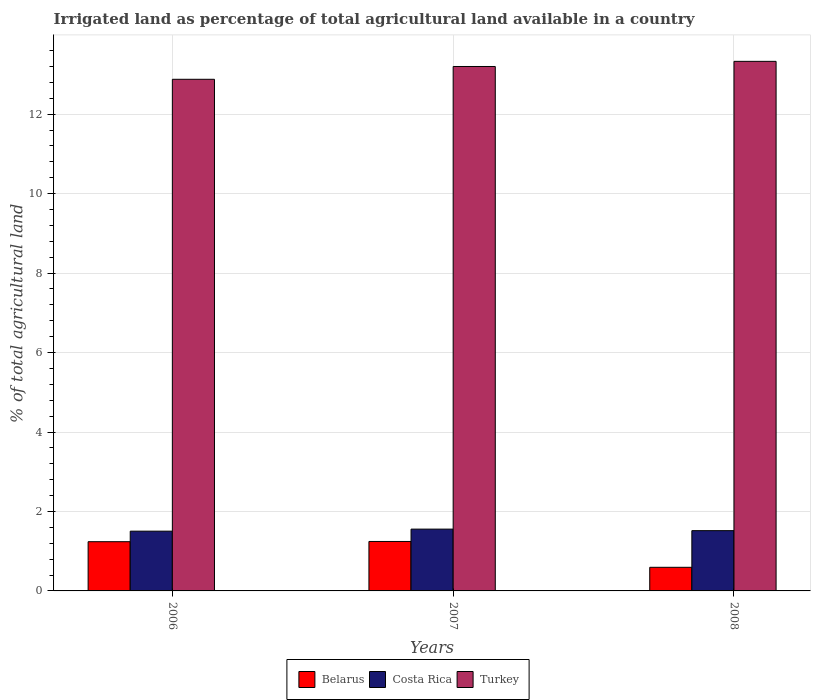How many bars are there on the 3rd tick from the left?
Offer a very short reply. 3. In how many cases, is the number of bars for a given year not equal to the number of legend labels?
Keep it short and to the point. 0. What is the percentage of irrigated land in Belarus in 2006?
Make the answer very short. 1.24. Across all years, what is the maximum percentage of irrigated land in Belarus?
Your response must be concise. 1.24. Across all years, what is the minimum percentage of irrigated land in Costa Rica?
Provide a short and direct response. 1.5. What is the total percentage of irrigated land in Costa Rica in the graph?
Provide a succinct answer. 4.58. What is the difference between the percentage of irrigated land in Belarus in 2006 and that in 2008?
Ensure brevity in your answer.  0.64. What is the difference between the percentage of irrigated land in Turkey in 2008 and the percentage of irrigated land in Belarus in 2006?
Keep it short and to the point. 12.09. What is the average percentage of irrigated land in Belarus per year?
Keep it short and to the point. 1.03. In the year 2008, what is the difference between the percentage of irrigated land in Costa Rica and percentage of irrigated land in Belarus?
Offer a very short reply. 0.92. What is the ratio of the percentage of irrigated land in Costa Rica in 2007 to that in 2008?
Give a very brief answer. 1.03. Is the percentage of irrigated land in Belarus in 2006 less than that in 2008?
Keep it short and to the point. No. Is the difference between the percentage of irrigated land in Costa Rica in 2007 and 2008 greater than the difference between the percentage of irrigated land in Belarus in 2007 and 2008?
Ensure brevity in your answer.  No. What is the difference between the highest and the second highest percentage of irrigated land in Turkey?
Ensure brevity in your answer.  0.13. What is the difference between the highest and the lowest percentage of irrigated land in Turkey?
Keep it short and to the point. 0.45. Is the sum of the percentage of irrigated land in Turkey in 2007 and 2008 greater than the maximum percentage of irrigated land in Costa Rica across all years?
Your answer should be compact. Yes. What does the 1st bar from the left in 2006 represents?
Offer a terse response. Belarus. Is it the case that in every year, the sum of the percentage of irrigated land in Turkey and percentage of irrigated land in Costa Rica is greater than the percentage of irrigated land in Belarus?
Provide a succinct answer. Yes. How many bars are there?
Your answer should be very brief. 9. What is the difference between two consecutive major ticks on the Y-axis?
Your answer should be compact. 2. What is the title of the graph?
Offer a very short reply. Irrigated land as percentage of total agricultural land available in a country. Does "Czech Republic" appear as one of the legend labels in the graph?
Give a very brief answer. No. What is the label or title of the Y-axis?
Provide a succinct answer. % of total agricultural land. What is the % of total agricultural land in Belarus in 2006?
Your answer should be compact. 1.24. What is the % of total agricultural land of Costa Rica in 2006?
Give a very brief answer. 1.5. What is the % of total agricultural land in Turkey in 2006?
Your response must be concise. 12.88. What is the % of total agricultural land of Belarus in 2007?
Offer a very short reply. 1.24. What is the % of total agricultural land of Costa Rica in 2007?
Ensure brevity in your answer.  1.56. What is the % of total agricultural land in Turkey in 2007?
Give a very brief answer. 13.2. What is the % of total agricultural land in Belarus in 2008?
Offer a terse response. 0.59. What is the % of total agricultural land in Costa Rica in 2008?
Keep it short and to the point. 1.52. What is the % of total agricultural land in Turkey in 2008?
Provide a succinct answer. 13.33. Across all years, what is the maximum % of total agricultural land in Belarus?
Provide a succinct answer. 1.24. Across all years, what is the maximum % of total agricultural land in Costa Rica?
Provide a short and direct response. 1.56. Across all years, what is the maximum % of total agricultural land of Turkey?
Your answer should be compact. 13.33. Across all years, what is the minimum % of total agricultural land in Belarus?
Your response must be concise. 0.59. Across all years, what is the minimum % of total agricultural land of Costa Rica?
Offer a very short reply. 1.5. Across all years, what is the minimum % of total agricultural land of Turkey?
Your response must be concise. 12.88. What is the total % of total agricultural land of Belarus in the graph?
Offer a very short reply. 3.08. What is the total % of total agricultural land of Costa Rica in the graph?
Your response must be concise. 4.58. What is the total % of total agricultural land of Turkey in the graph?
Offer a very short reply. 39.41. What is the difference between the % of total agricultural land in Belarus in 2006 and that in 2007?
Offer a very short reply. -0.01. What is the difference between the % of total agricultural land of Costa Rica in 2006 and that in 2007?
Keep it short and to the point. -0.05. What is the difference between the % of total agricultural land of Turkey in 2006 and that in 2007?
Make the answer very short. -0.32. What is the difference between the % of total agricultural land of Belarus in 2006 and that in 2008?
Offer a very short reply. 0.64. What is the difference between the % of total agricultural land in Costa Rica in 2006 and that in 2008?
Make the answer very short. -0.01. What is the difference between the % of total agricultural land in Turkey in 2006 and that in 2008?
Make the answer very short. -0.45. What is the difference between the % of total agricultural land in Belarus in 2007 and that in 2008?
Offer a very short reply. 0.65. What is the difference between the % of total agricultural land of Costa Rica in 2007 and that in 2008?
Make the answer very short. 0.04. What is the difference between the % of total agricultural land in Turkey in 2007 and that in 2008?
Make the answer very short. -0.13. What is the difference between the % of total agricultural land in Belarus in 2006 and the % of total agricultural land in Costa Rica in 2007?
Provide a short and direct response. -0.32. What is the difference between the % of total agricultural land of Belarus in 2006 and the % of total agricultural land of Turkey in 2007?
Provide a short and direct response. -11.96. What is the difference between the % of total agricultural land of Costa Rica in 2006 and the % of total agricultural land of Turkey in 2007?
Make the answer very short. -11.7. What is the difference between the % of total agricultural land of Belarus in 2006 and the % of total agricultural land of Costa Rica in 2008?
Your answer should be very brief. -0.28. What is the difference between the % of total agricultural land in Belarus in 2006 and the % of total agricultural land in Turkey in 2008?
Offer a terse response. -12.09. What is the difference between the % of total agricultural land of Costa Rica in 2006 and the % of total agricultural land of Turkey in 2008?
Keep it short and to the point. -11.83. What is the difference between the % of total agricultural land in Belarus in 2007 and the % of total agricultural land in Costa Rica in 2008?
Your response must be concise. -0.27. What is the difference between the % of total agricultural land in Belarus in 2007 and the % of total agricultural land in Turkey in 2008?
Offer a terse response. -12.09. What is the difference between the % of total agricultural land in Costa Rica in 2007 and the % of total agricultural land in Turkey in 2008?
Give a very brief answer. -11.77. What is the average % of total agricultural land in Belarus per year?
Provide a succinct answer. 1.03. What is the average % of total agricultural land of Costa Rica per year?
Ensure brevity in your answer.  1.53. What is the average % of total agricultural land in Turkey per year?
Ensure brevity in your answer.  13.14. In the year 2006, what is the difference between the % of total agricultural land in Belarus and % of total agricultural land in Costa Rica?
Your answer should be compact. -0.27. In the year 2006, what is the difference between the % of total agricultural land of Belarus and % of total agricultural land of Turkey?
Provide a succinct answer. -11.64. In the year 2006, what is the difference between the % of total agricultural land of Costa Rica and % of total agricultural land of Turkey?
Your answer should be very brief. -11.37. In the year 2007, what is the difference between the % of total agricultural land of Belarus and % of total agricultural land of Costa Rica?
Keep it short and to the point. -0.31. In the year 2007, what is the difference between the % of total agricultural land in Belarus and % of total agricultural land in Turkey?
Your answer should be very brief. -11.96. In the year 2007, what is the difference between the % of total agricultural land in Costa Rica and % of total agricultural land in Turkey?
Ensure brevity in your answer.  -11.65. In the year 2008, what is the difference between the % of total agricultural land in Belarus and % of total agricultural land in Costa Rica?
Make the answer very short. -0.92. In the year 2008, what is the difference between the % of total agricultural land of Belarus and % of total agricultural land of Turkey?
Give a very brief answer. -12.74. In the year 2008, what is the difference between the % of total agricultural land of Costa Rica and % of total agricultural land of Turkey?
Make the answer very short. -11.81. What is the ratio of the % of total agricultural land in Belarus in 2006 to that in 2007?
Offer a terse response. 1. What is the ratio of the % of total agricultural land in Costa Rica in 2006 to that in 2007?
Give a very brief answer. 0.97. What is the ratio of the % of total agricultural land in Turkey in 2006 to that in 2007?
Ensure brevity in your answer.  0.98. What is the ratio of the % of total agricultural land of Belarus in 2006 to that in 2008?
Provide a succinct answer. 2.08. What is the ratio of the % of total agricultural land of Turkey in 2006 to that in 2008?
Give a very brief answer. 0.97. What is the ratio of the % of total agricultural land of Belarus in 2007 to that in 2008?
Keep it short and to the point. 2.09. What is the ratio of the % of total agricultural land of Costa Rica in 2007 to that in 2008?
Provide a succinct answer. 1.03. What is the ratio of the % of total agricultural land in Turkey in 2007 to that in 2008?
Make the answer very short. 0.99. What is the difference between the highest and the second highest % of total agricultural land in Belarus?
Keep it short and to the point. 0.01. What is the difference between the highest and the second highest % of total agricultural land in Costa Rica?
Make the answer very short. 0.04. What is the difference between the highest and the second highest % of total agricultural land in Turkey?
Offer a very short reply. 0.13. What is the difference between the highest and the lowest % of total agricultural land in Belarus?
Provide a short and direct response. 0.65. What is the difference between the highest and the lowest % of total agricultural land of Costa Rica?
Provide a short and direct response. 0.05. What is the difference between the highest and the lowest % of total agricultural land of Turkey?
Offer a very short reply. 0.45. 